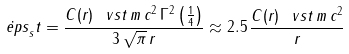<formula> <loc_0><loc_0><loc_500><loc_500>\dot { \ e p s } _ { s } t = \frac { C ( r ) \, \ v s t \, m \, c ^ { 2 } \, \Gamma ^ { 2 } \left ( \frac { 1 } { 4 } \right ) } { 3 \, \sqrt { \pi } \, r } \approx 2 . 5 \, \frac { C ( r ) \, \ v s t \, m \, c ^ { 2 } } { r }</formula> 